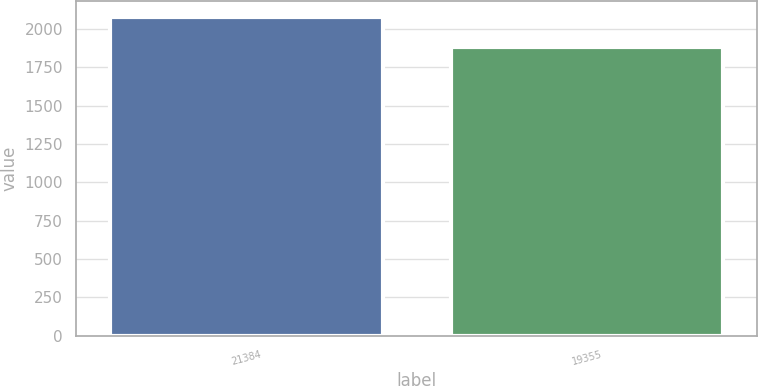Convert chart. <chart><loc_0><loc_0><loc_500><loc_500><bar_chart><fcel>21384<fcel>19355<nl><fcel>2076.5<fcel>1883<nl></chart> 